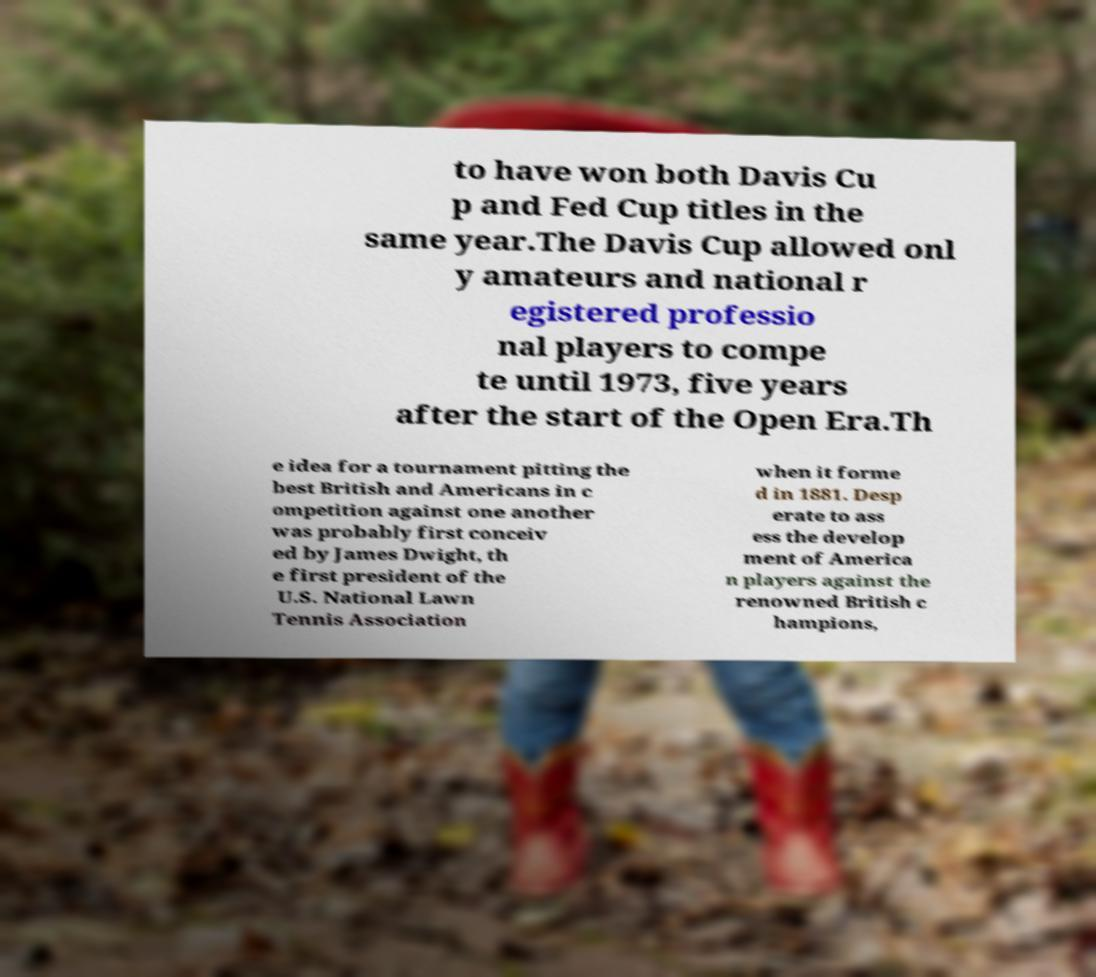Please identify and transcribe the text found in this image. to have won both Davis Cu p and Fed Cup titles in the same year.The Davis Cup allowed onl y amateurs and national r egistered professio nal players to compe te until 1973, five years after the start of the Open Era.Th e idea for a tournament pitting the best British and Americans in c ompetition against one another was probably first conceiv ed by James Dwight, th e first president of the U.S. National Lawn Tennis Association when it forme d in 1881. Desp erate to ass ess the develop ment of America n players against the renowned British c hampions, 